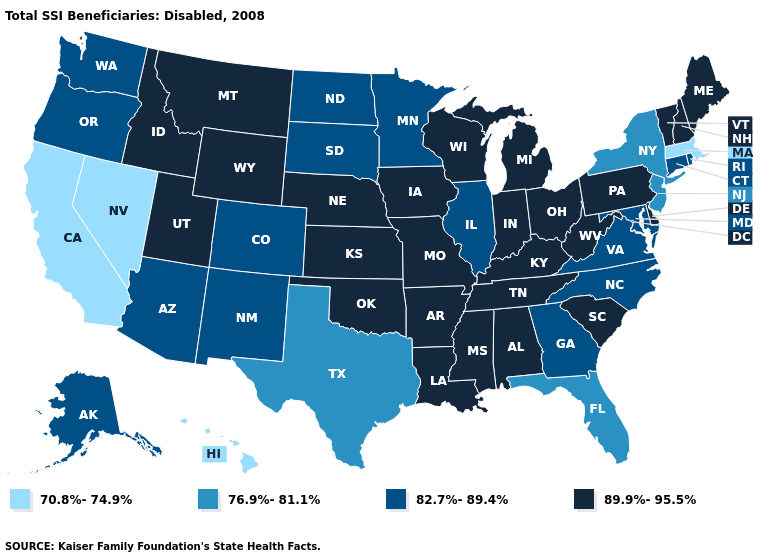What is the value of Michigan?
Keep it brief. 89.9%-95.5%. What is the value of Colorado?
Quick response, please. 82.7%-89.4%. Does the first symbol in the legend represent the smallest category?
Quick response, please. Yes. What is the value of Vermont?
Short answer required. 89.9%-95.5%. Among the states that border Colorado , does Nebraska have the highest value?
Concise answer only. Yes. Does Minnesota have the lowest value in the MidWest?
Keep it brief. Yes. How many symbols are there in the legend?
Short answer required. 4. Among the states that border Alabama , which have the highest value?
Short answer required. Mississippi, Tennessee. What is the value of Tennessee?
Concise answer only. 89.9%-95.5%. Among the states that border Mississippi , which have the highest value?
Keep it brief. Alabama, Arkansas, Louisiana, Tennessee. What is the highest value in the USA?
Give a very brief answer. 89.9%-95.5%. What is the value of Idaho?
Short answer required. 89.9%-95.5%. Does California have the lowest value in the USA?
Short answer required. Yes. What is the highest value in states that border Nevada?
Answer briefly. 89.9%-95.5%. Name the states that have a value in the range 70.8%-74.9%?
Quick response, please. California, Hawaii, Massachusetts, Nevada. 